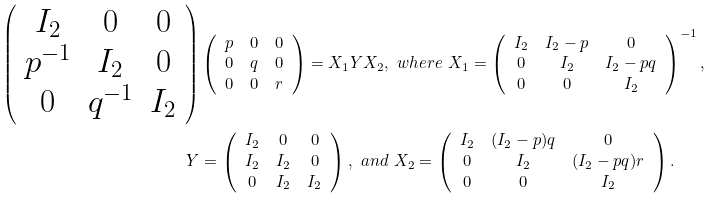Convert formula to latex. <formula><loc_0><loc_0><loc_500><loc_500>\left ( \begin{array} { c c c } I _ { 2 } & 0 & 0 \\ p ^ { - 1 } & I _ { 2 } & 0 \\ 0 & q ^ { - 1 } & I _ { 2 } \end{array} \right ) & \left ( \begin{array} { c c c } p & 0 & 0 \\ 0 & q & 0 \\ 0 & 0 & r \end{array} \right ) = X _ { 1 } Y X _ { 2 } , \ w h e r e \ X _ { 1 } = \left ( \begin{array} { c c c } I _ { 2 } & I _ { 2 } - p & 0 \\ 0 & I _ { 2 } & I _ { 2 } - p q \\ 0 & 0 & I _ { 2 } \end{array} \right ) ^ { - 1 } , \\ Y & = \left ( \begin{array} { c c c } I _ { 2 } & 0 & 0 \\ I _ { 2 } & I _ { 2 } & 0 \\ 0 & I _ { 2 } & I _ { 2 } \end{array} \right ) , \ a n d \ X _ { 2 } = \left ( \begin{array} { c c c } I _ { 2 } & ( I _ { 2 } - p ) q & 0 \\ 0 & I _ { 2 } & ( I _ { 2 } - p q ) r \\ 0 & 0 & I _ { 2 } \end{array} \right ) .</formula> 